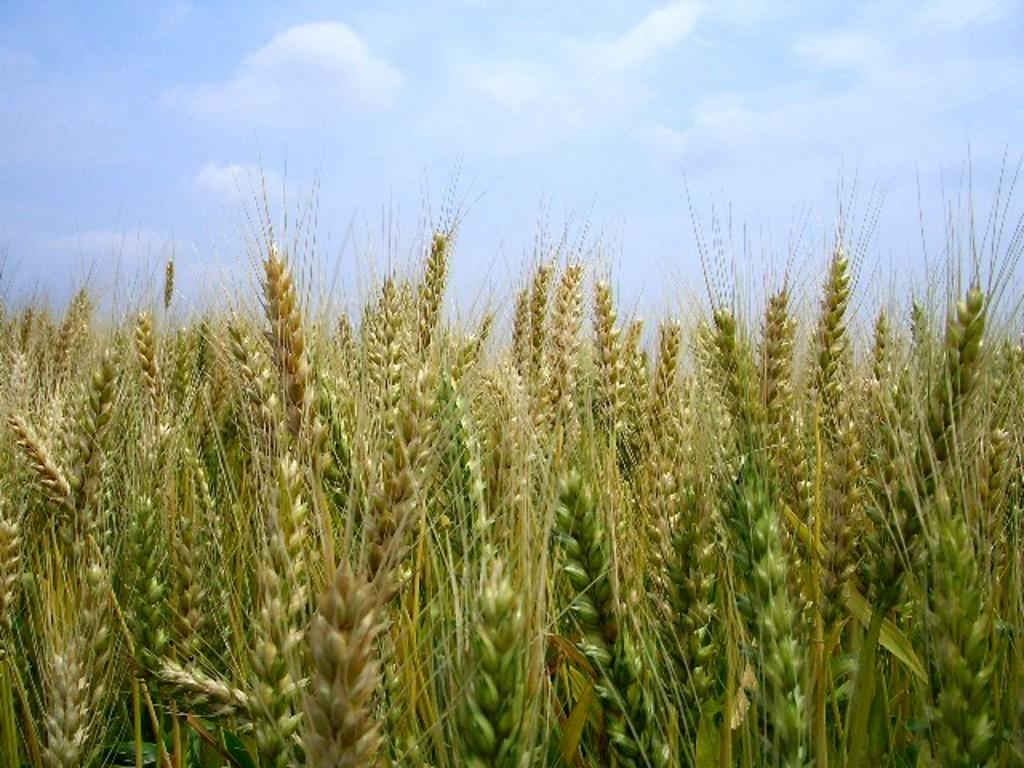What type of plant material is present in the image? There are wheat germs in the image. What can be seen in the sky in the image? There are clouds visible in the sky. What type of houses can be seen in the image? There are no houses present in the image; it only features wheat germs and clouds in the sky. What division of labor is depicted in the image? There is no division of labor depicted in the image, as it only contains wheat germs and clouds in the sky. 